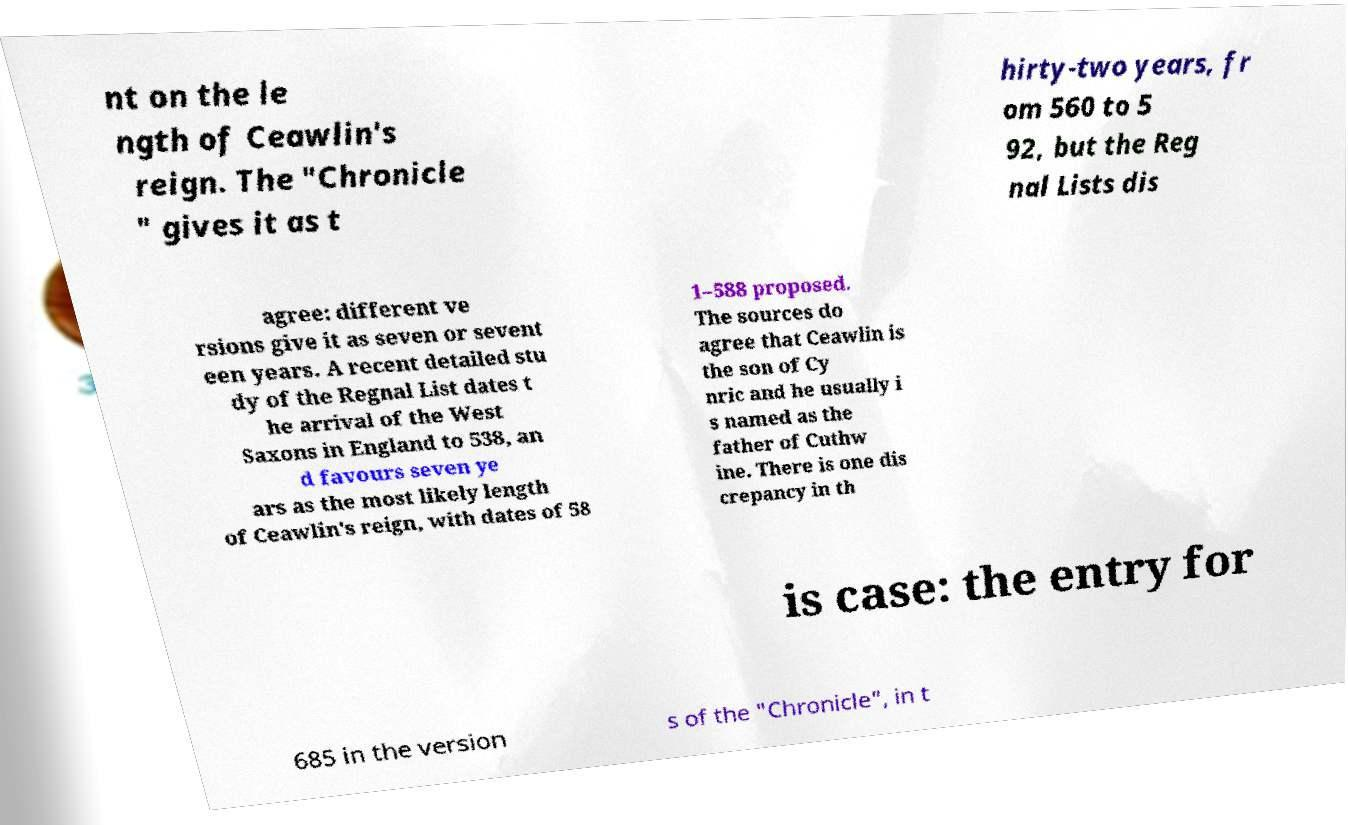For documentation purposes, I need the text within this image transcribed. Could you provide that? nt on the le ngth of Ceawlin's reign. The "Chronicle " gives it as t hirty-two years, fr om 560 to 5 92, but the Reg nal Lists dis agree: different ve rsions give it as seven or sevent een years. A recent detailed stu dy of the Regnal List dates t he arrival of the West Saxons in England to 538, an d favours seven ye ars as the most likely length of Ceawlin's reign, with dates of 58 1–588 proposed. The sources do agree that Ceawlin is the son of Cy nric and he usually i s named as the father of Cuthw ine. There is one dis crepancy in th is case: the entry for 685 in the version s of the "Chronicle", in t 